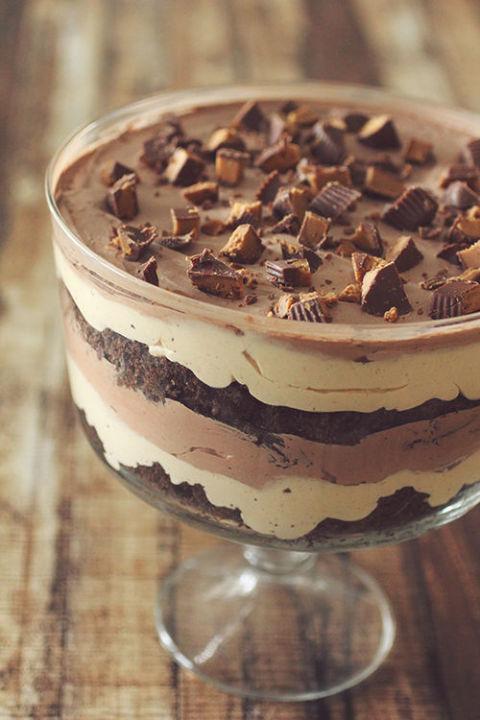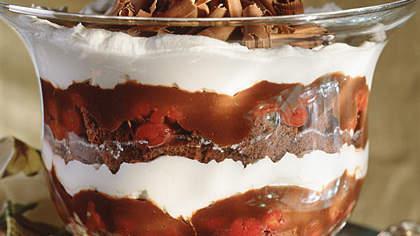The first image is the image on the left, the second image is the image on the right. Analyze the images presented: Is the assertion "A spoon is sitting on the left of the dessert bowls in at least one of the images." valid? Answer yes or no. No. 